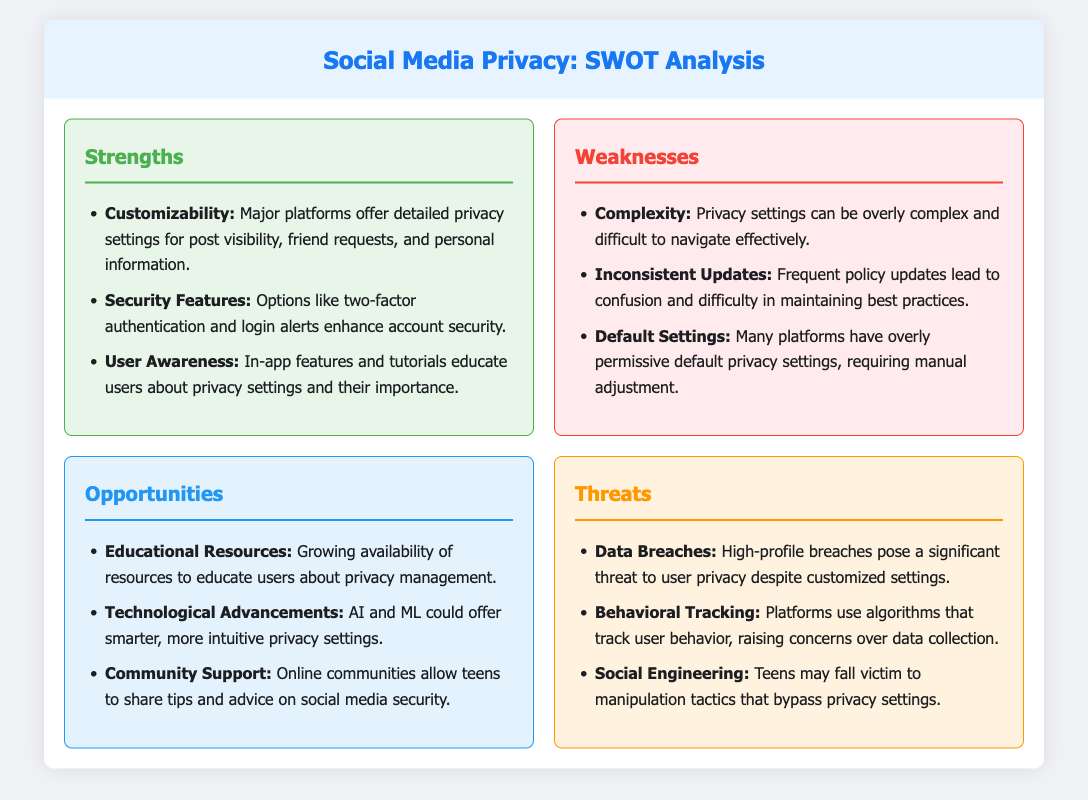What are the strengths of social media privacy settings? The strengths section lists major features that enhance user privacy, such as customizability, security features, and user awareness.
Answer: Customizability, Security Features, User Awareness What is a significant weakness mentioned in the document? The weaknesses section highlights specific drawbacks related to the complexity and management of privacy settings.
Answer: Complexity What opportunity involves technological advancements? The opportunities section mentions advancements in technology that could improve privacy management for users.
Answer: AI and ML could offer smarter, more intuitive privacy settings What type of threat involves user manipulation? The threats section discusses several risks that impact users, including tactics used to bypass privacy settings.
Answer: Social Engineering How many strengths are listed in the SWOT analysis? The strengths section enumerates specific features enhancing privacy settings, contributing to the total count of strengths.
Answer: Three What color represents the weaknesses section? Each section has a specific background color to visually differentiate them in the document.
Answer: Red 